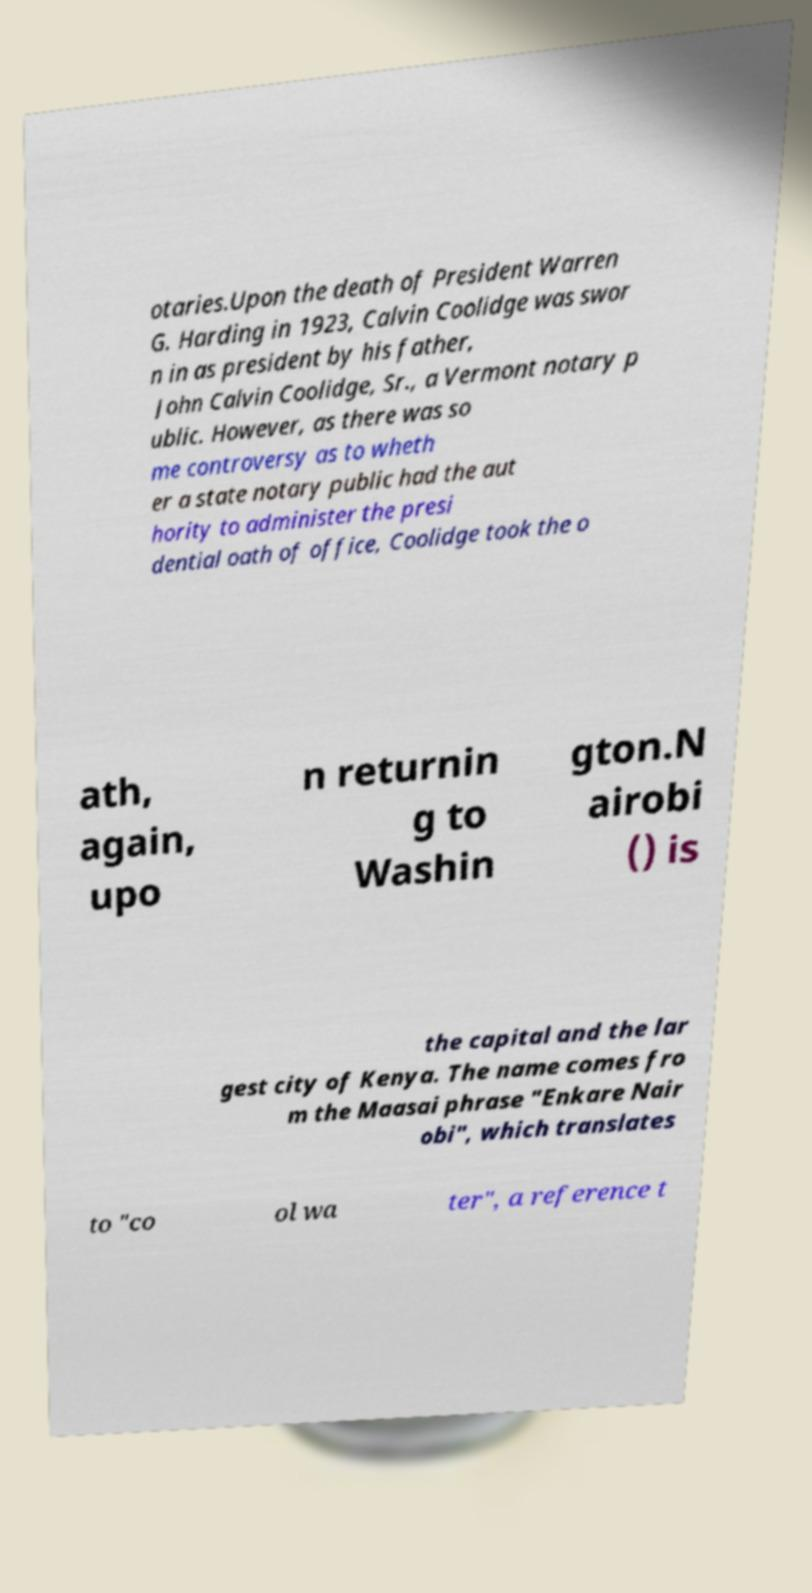I need the written content from this picture converted into text. Can you do that? otaries.Upon the death of President Warren G. Harding in 1923, Calvin Coolidge was swor n in as president by his father, John Calvin Coolidge, Sr., a Vermont notary p ublic. However, as there was so me controversy as to wheth er a state notary public had the aut hority to administer the presi dential oath of office, Coolidge took the o ath, again, upo n returnin g to Washin gton.N airobi () is the capital and the lar gest city of Kenya. The name comes fro m the Maasai phrase "Enkare Nair obi", which translates to "co ol wa ter", a reference t 